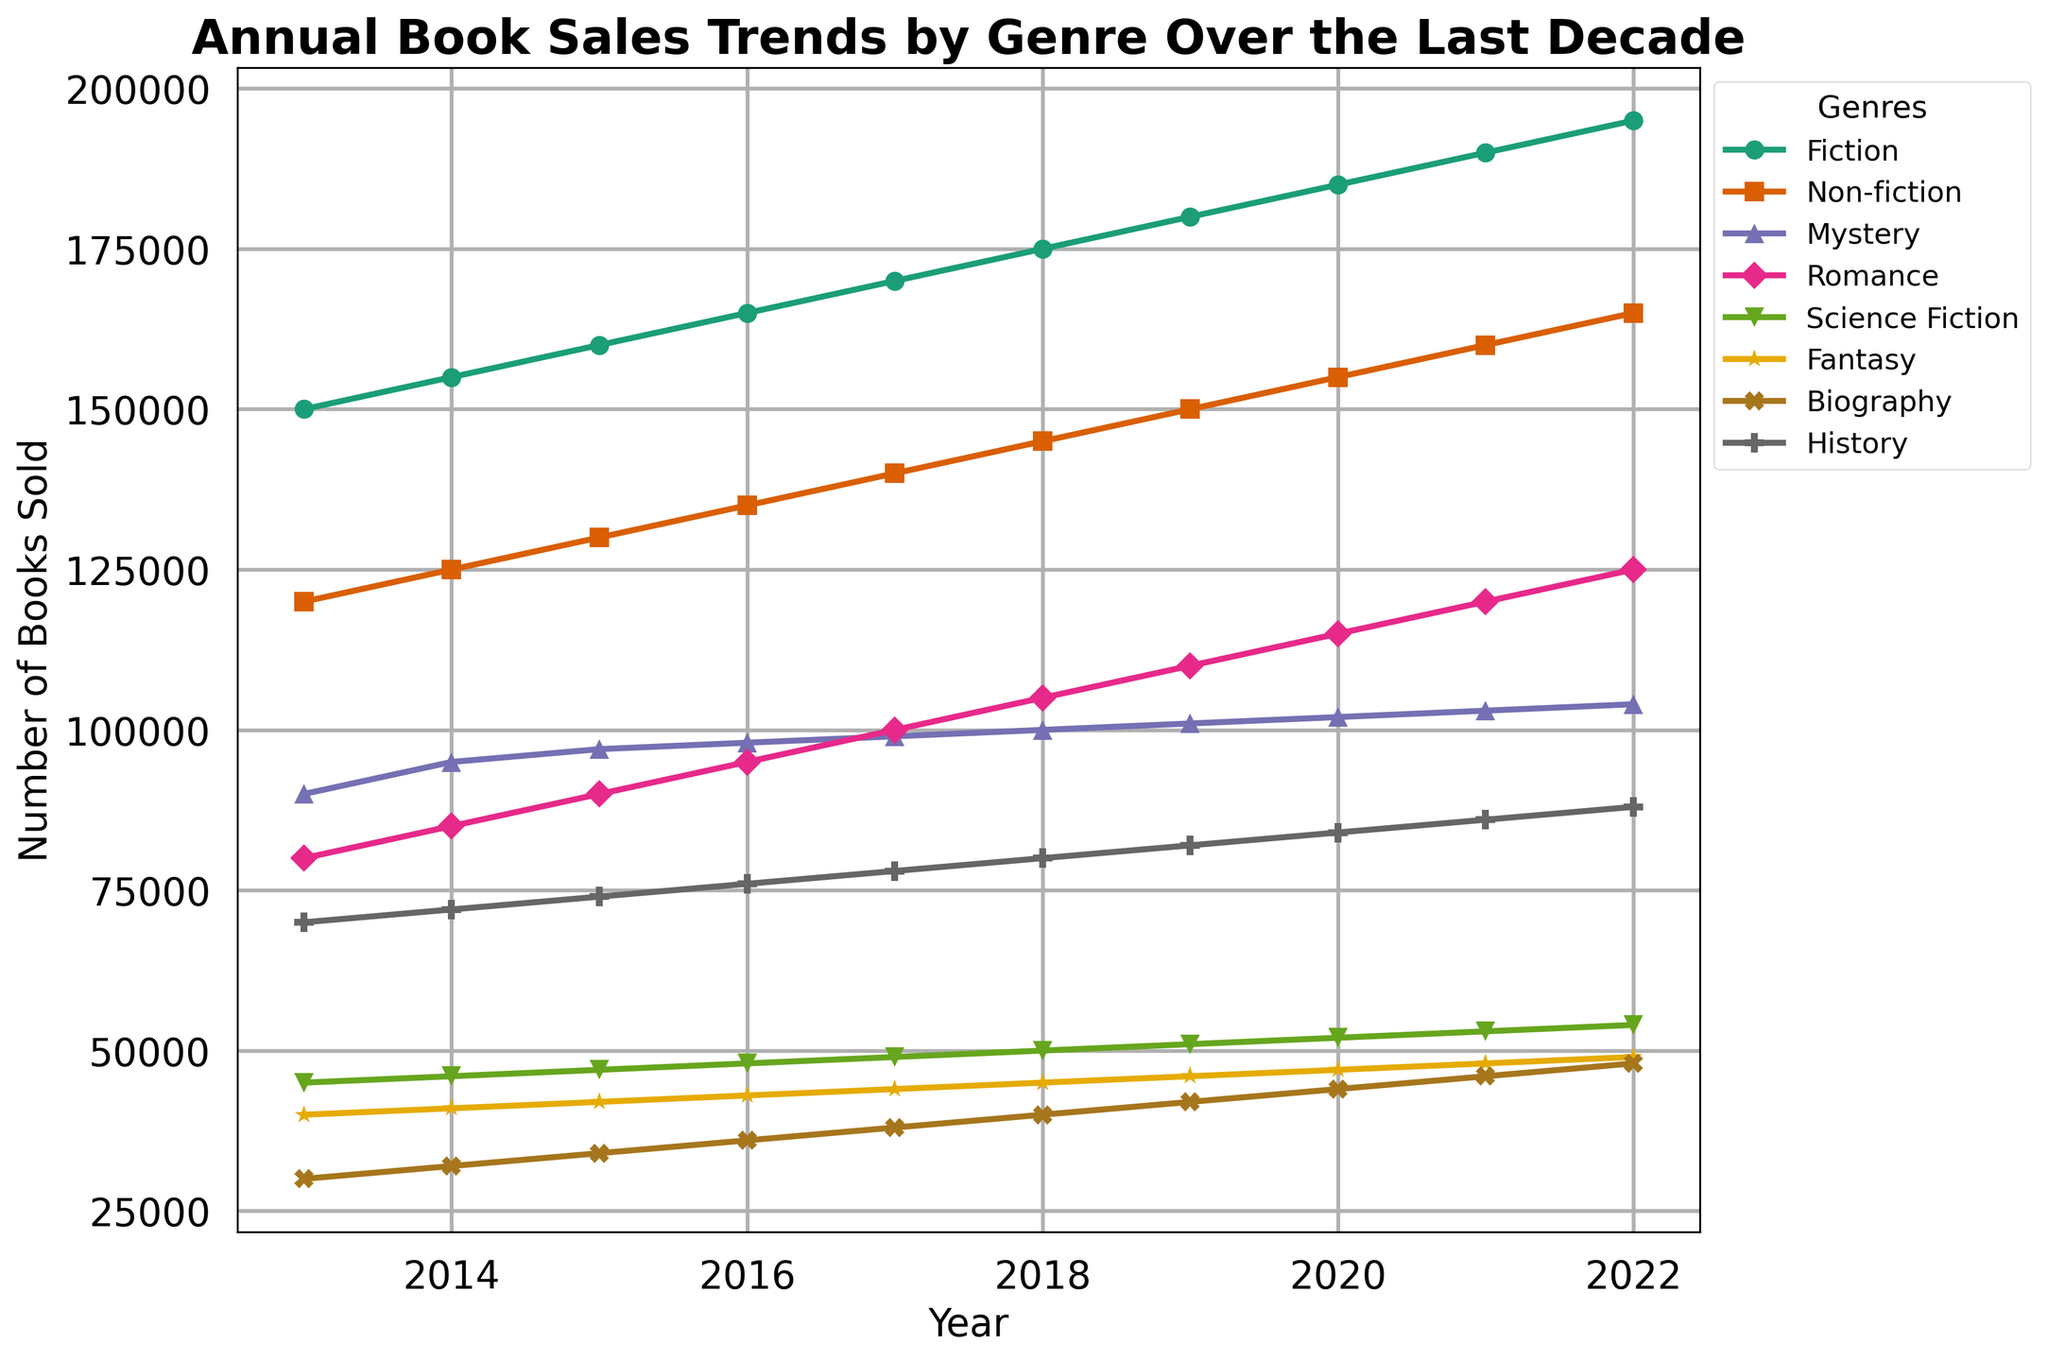What genre experienced the highest sales increase over the last decade? To determine which genre experienced the highest sales increase, subtract the 2013 sales from the 2022 sales for each genre and compare. The differences are as follows: Fiction (195000-150000=45000), Non-fiction (165000-120000=45000), Mystery (104000-90000=14000), Romance (125000-80000=45000), Science Fiction (54000-45000=9000), Fantasy (49000-40000=9000), Biography (48000-30000=18000), History (88000-70000=18000). Multiple genres increased by 45000 (Fiction, Non-fiction, Romance).
Answer: Fiction, Non-fiction, Romance (tie) Which genre showed the smallest increase in sales over the decade? To find the smallest increase, calculate the difference for each genre from 2013 to 2022, then compare. The differences are: Fiction (45000), Non-fiction (45000), Mystery (14000), Romance (45000), Science Fiction (9000), Fantasy (9000), Biography (18000), History (18000). The smallest increase is observed in Science Fiction and Fantasy.
Answer: Science Fiction, Fantasy (tie) Which genres had more than 100,000 books sold in the year 2022? Check the 2022 data: Fiction (195000), Non-fiction (165000), Mystery (104000), Romance (125000), Science Fiction (54000), Fantasy (49000), Biography (48000), History (88000). Fiction, Non-fiction, Mystery, and Romance all had sales more than 100,000.
Answer: Fiction, Non-fiction, Mystery, Romance What is the average number of books sold in 2022 across all genres? Sum the 2022 sales for all genres: 195000 + 165000 + 104000 + 125000 + 54000 + 49000 + 48000 + 88000 = 828000. There are 8 genres, so the average is 828000 / 8 = 103500.
Answer: 103500 Which genre had a consistent annual increase every year? Inspect the sales data year by year. Fiction (consistent increase), Non-fiction (consistent increase), Mystery (consistent increase), Romance (consistent increase), Science Fiction (consistent increase), Fantasy (consistent increase), Biography (consistent increase), and History (consistent increase). All genres had consistent annual increases.
Answer: All genres Compare the sales numbers of Fiction and Non-fiction in the year 2013. Which one was higher and by how much? The sales in 2013 for Fiction were 150000, and for Non-fiction, they were 120000. Fiction - Non-fiction = 150000 - 120000 = 30000. Fiction was higher by 30000.
Answer: Fiction by 30000 By how much did the sales of Romance increase from 2013 to 2020? The sales in 2013 for Romance were 80000 and in 2020 were 115000. Increase = 115000 - 80000 = 35000.
Answer: 35000 What is the combined sales number for Science Fiction and Fantasy in 2013? Add the sales numbers for Science Fiction (45000) and Fantasy (40000) in 2013. Combined sales = 45000 + 40000 = 85000.
Answer: 85000 